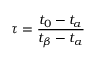Convert formula to latex. <formula><loc_0><loc_0><loc_500><loc_500>\tau = \frac { t _ { 0 } - t _ { \alpha } } { t _ { \beta } - t _ { \alpha } }</formula> 